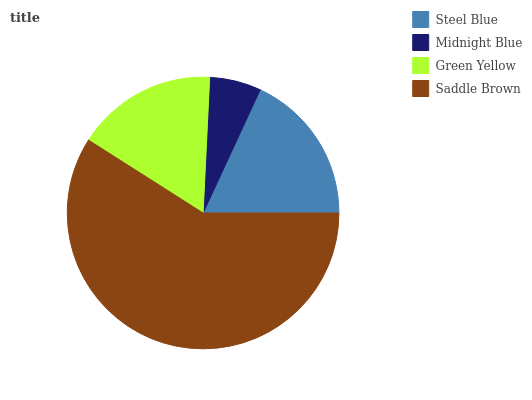Is Midnight Blue the minimum?
Answer yes or no. Yes. Is Saddle Brown the maximum?
Answer yes or no. Yes. Is Green Yellow the minimum?
Answer yes or no. No. Is Green Yellow the maximum?
Answer yes or no. No. Is Green Yellow greater than Midnight Blue?
Answer yes or no. Yes. Is Midnight Blue less than Green Yellow?
Answer yes or no. Yes. Is Midnight Blue greater than Green Yellow?
Answer yes or no. No. Is Green Yellow less than Midnight Blue?
Answer yes or no. No. Is Steel Blue the high median?
Answer yes or no. Yes. Is Green Yellow the low median?
Answer yes or no. Yes. Is Midnight Blue the high median?
Answer yes or no. No. Is Midnight Blue the low median?
Answer yes or no. No. 